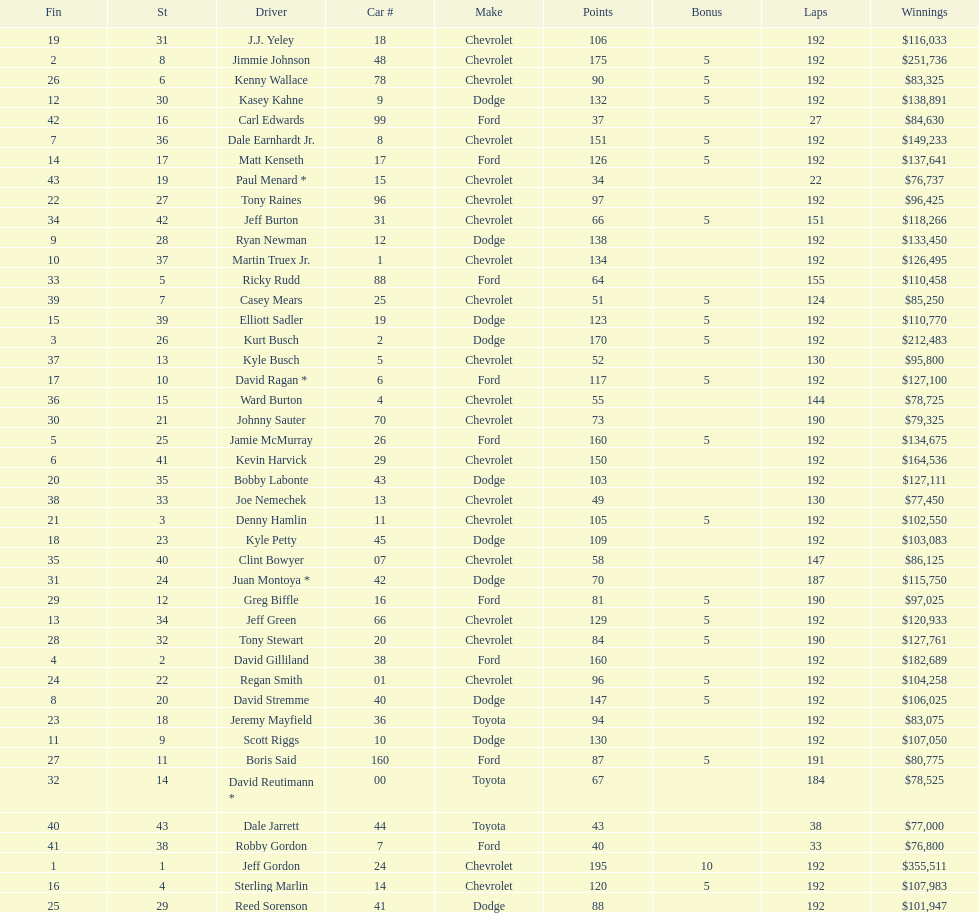How many drivers placed below tony stewart? 15. 